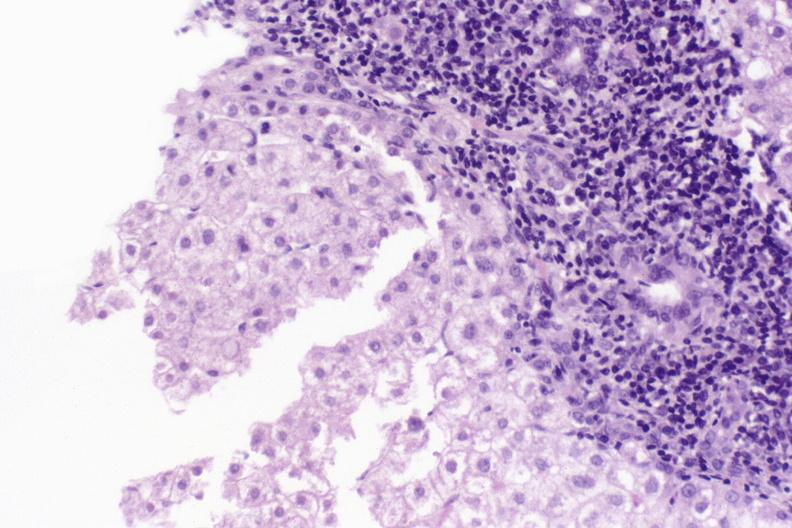what is present?
Answer the question using a single word or phrase. Hepatobiliary 